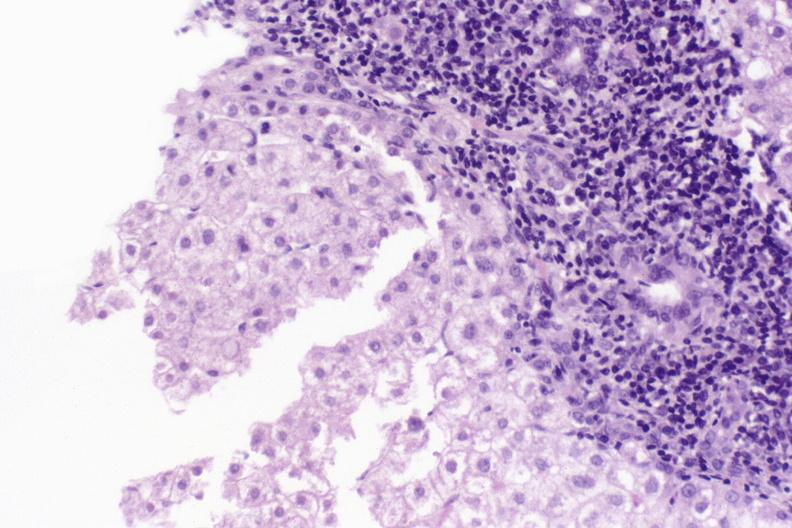what is present?
Answer the question using a single word or phrase. Hepatobiliary 